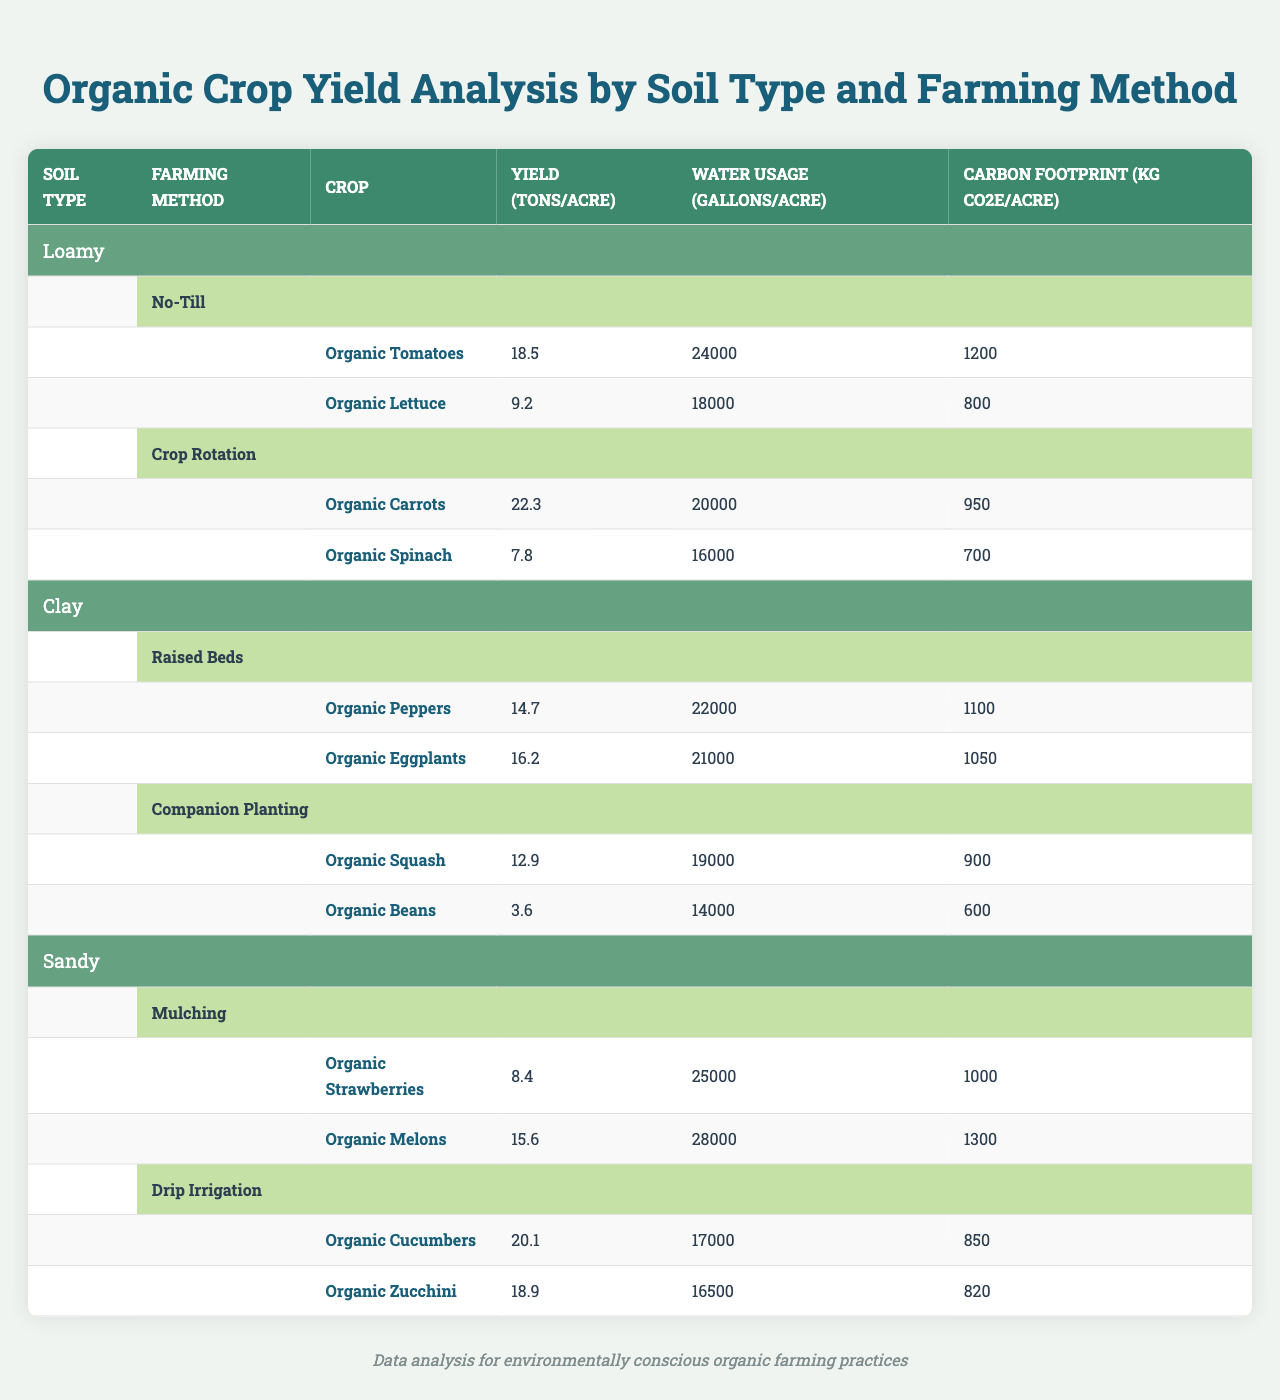What is the yield of Organic Tomatoes grown using No-Till farming method on Loamy soil? From the table, the yield of Organic Tomatoes under No-Till farming method on Loamy soil is directly mentioned as 18.5 tons per acre.
Answer: 18.5 tons/acre Which farming method produces the highest yield for Organic Carrots? According to the table, Organic Carrots are grown using Crop Rotation on Loamy soil, which has the highest yield at 22.3 tons per acre compared to any other method listed.
Answer: Crop Rotation What is the water usage for Organic Mellons on Sandy soil using Mulching? The table lists that Organic Melons use 28,000 gallons per acre when grown using Mulching method on Sandy soil.
Answer: 28,000 gallons/acre True or False: Organic Beans have a higher yield than Organic Squash when grown in clay soil. The table states that Organic Squash yields 12.9 tons per acre while Organic Beans only yield 3.6 tons per acre, indicating that Organic Beans do not have a higher yield.
Answer: False What is the average yield of crops grown using Crop Rotation and No-Till methods? The yields for crops using Crop Rotation (Organic Carrots: 22.3 tons/acre and Organic Spinach: 7.8 tons/acre) sum to 30.1 tons/acre, while crops using No-Till (Organic Tomatoes: 18.5 tons/acre and Organic Lettuce: 9.2 tons/acre) total 27.7 tons/acre. Combining both is 30.1 + 27.7 = 57.8 tons; dividing by the four crops results in an average yield of 57.8 / 4 = 14.45 tons/acre.
Answer: 14.45 tons/acre Which soil type has the lowest carbon footprint for its cropping methods? Examining the carbon footprints listed in the table: Loamy soils have 1200 and 800 kg CO2e per acre; Clay soils have 1100 and 1050 kg CO2e; and Sandy soils show 1000 and 1300 kg CO2e. Thus, Clay soils with values of 600 kg and 900 kg have the minimum average, indicating it has the lowest impact.
Answer: Clay soil What’s the difference in water usage between Organic Cucumbers and Organic Lettuce? The water usage for Organic Cucumbers is 17,000 gallons per acre and for Organic Lettuce it's 18,000 gallons. The difference is calculated by subtracting the cucumber's usage from the lettuce’s: 18,000 - 17,000 = 1,000 gallons.
Answer: 1,000 gallons Which crop has the highest carbon footprint among those listed? By reviewing the carbon footprints for all crops: Organic Tomatoes (1200 kg), Organic Lettuce (800 kg), Organic Carrots (950 kg), Organic Spinach (700 kg), Organic Peppers (1100 kg), Organic Eggplants (1050 kg), Organic Squash (900 kg), Organic Beans (600 kg), Organic Strawberries (1000 kg), Organic Melons (1300 kg), Organic Cucumbers (850 kg), and Organic Zucchini (820 kg), it is clear that Organic Melons at 1300 kg CO2e/acre have the highest footprint.
Answer: Organic Melons How many crops yield more than 15 tons per acre? From the table, the listed crops that yield more than 15 tons per acre are Organic Tomatoes (18.5), Organic Carrots (22.3), Organic Peppers (14.7), Organic Eggplants (16.2), Organic Cucumbers (20.1), and Organic Zucchini (18.9). Counting these gives a total of 6 crops.
Answer: 6 crops What is the overall average water usage for all crops in the table? The total water usage values sum to: (24000 + 18000 + 20000 + 16000 + 22000 + 21000 + 19000 + 14000 + 25000 + 28000 + 17000 + 16500) = 238000 gallons. With 12 crops present, the average is calculated as 238000 / 12 = 19833.33 gallons per acre.
Answer: 19833.33 gallons/acre 